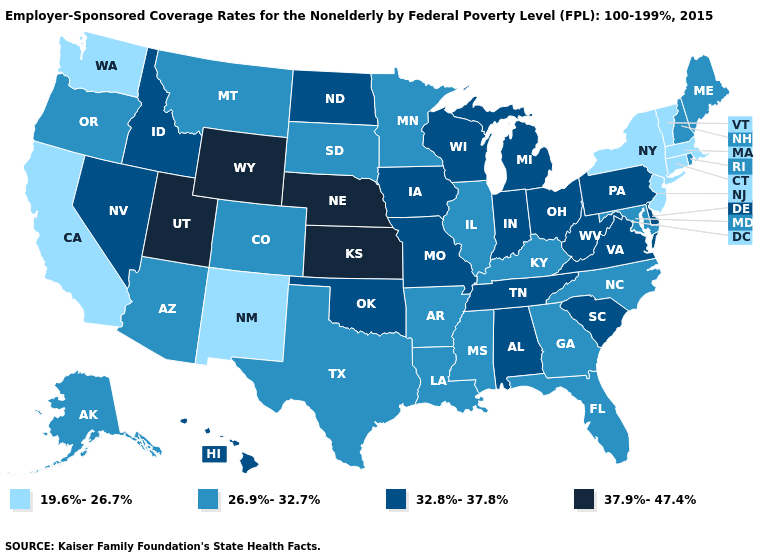What is the highest value in states that border West Virginia?
Short answer required. 32.8%-37.8%. Name the states that have a value in the range 32.8%-37.8%?
Keep it brief. Alabama, Delaware, Hawaii, Idaho, Indiana, Iowa, Michigan, Missouri, Nevada, North Dakota, Ohio, Oklahoma, Pennsylvania, South Carolina, Tennessee, Virginia, West Virginia, Wisconsin. What is the value of California?
Keep it brief. 19.6%-26.7%. What is the value of Utah?
Be succinct. 37.9%-47.4%. Does Florida have the lowest value in the South?
Answer briefly. Yes. Name the states that have a value in the range 19.6%-26.7%?
Keep it brief. California, Connecticut, Massachusetts, New Jersey, New Mexico, New York, Vermont, Washington. What is the value of North Dakota?
Be succinct. 32.8%-37.8%. What is the value of Texas?
Answer briefly. 26.9%-32.7%. How many symbols are there in the legend?
Quick response, please. 4. Does Nebraska have the lowest value in the MidWest?
Give a very brief answer. No. Name the states that have a value in the range 37.9%-47.4%?
Quick response, please. Kansas, Nebraska, Utah, Wyoming. What is the lowest value in the USA?
Keep it brief. 19.6%-26.7%. Name the states that have a value in the range 19.6%-26.7%?
Quick response, please. California, Connecticut, Massachusetts, New Jersey, New Mexico, New York, Vermont, Washington. Does Michigan have the highest value in the MidWest?
Answer briefly. No. Does Arkansas have the highest value in the South?
Be succinct. No. 